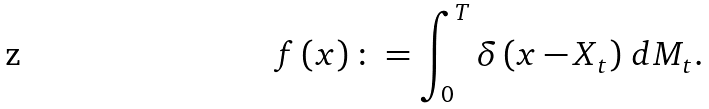Convert formula to latex. <formula><loc_0><loc_0><loc_500><loc_500>f \left ( x \right ) \colon = \int _ { 0 } ^ { T } \delta \left ( x - X _ { t } \right ) \, d M _ { t } .</formula> 